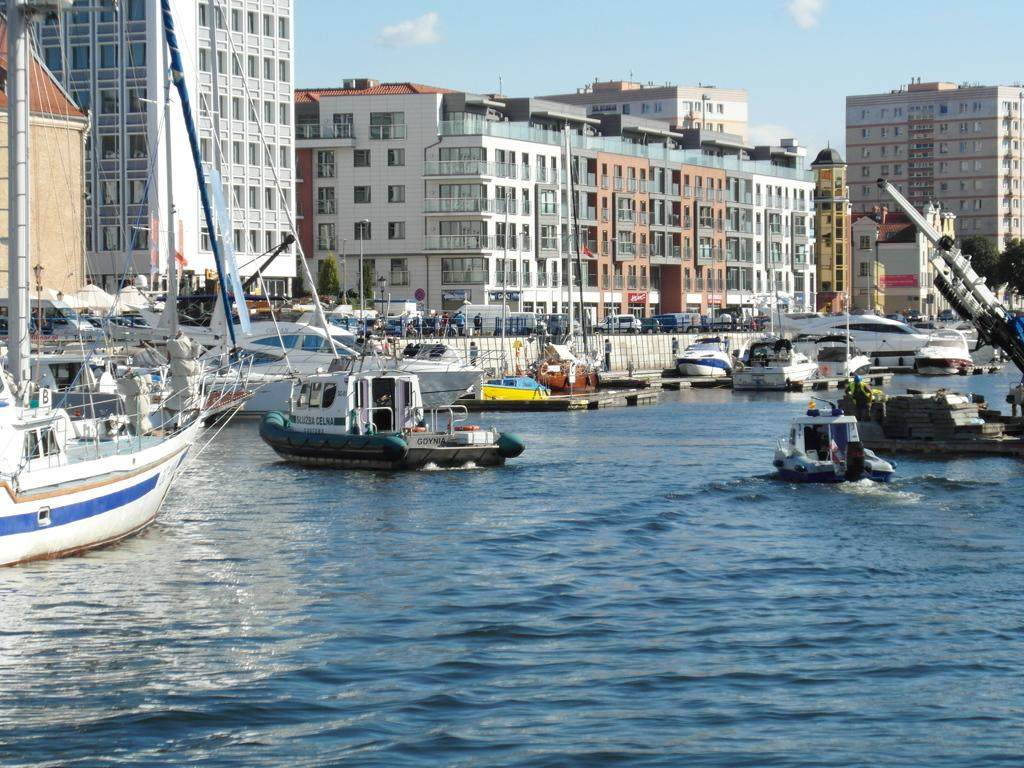What type of vehicles can be seen on the water in the image? There are boats on the water in the image. What structures are visible in the image? There are buildings in the image. What objects are present in the image that are not buildings or boats? There are poles and trees in the image. What can be seen in the background of the image? The sky is visible in the background of the image. Where is the store located in the image? There is no store present in the image. What type of jewel can be seen on the trees in the image? There are no jewels present on the trees in the image. 